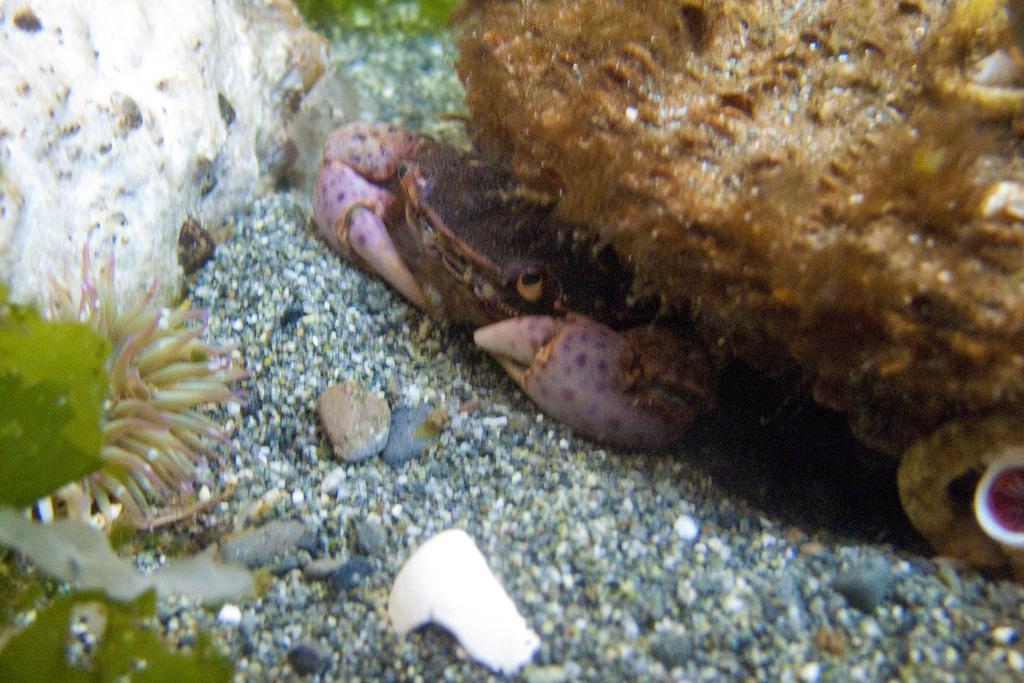How would you summarize this image in a sentence or two? In this picture we can see a crab, stones and in the background we can see green color. 